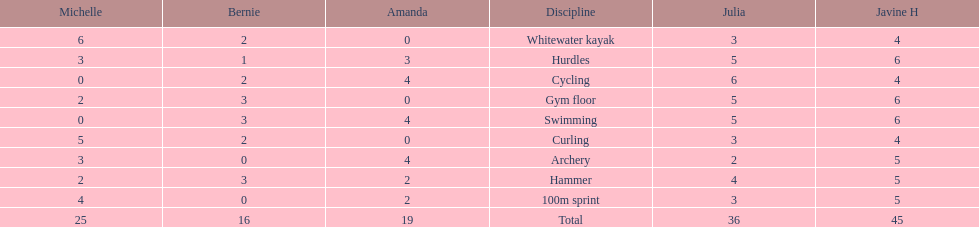What is the average score on 100m sprint? 2.8. Can you give me this table as a dict? {'header': ['Michelle', 'Bernie', 'Amanda', 'Discipline', 'Julia', 'Javine H'], 'rows': [['6', '2', '0', 'Whitewater kayak', '3', '4'], ['3', '1', '3', 'Hurdles', '5', '6'], ['0', '2', '4', 'Cycling', '6', '4'], ['2', '3', '0', 'Gym floor', '5', '6'], ['0', '3', '4', 'Swimming', '5', '6'], ['5', '2', '0', 'Curling', '3', '4'], ['3', '0', '4', 'Archery', '2', '5'], ['2', '3', '2', 'Hammer', '4', '5'], ['4', '0', '2', '100m sprint', '3', '5'], ['25', '16', '19', 'Total', '36', '45']]} 